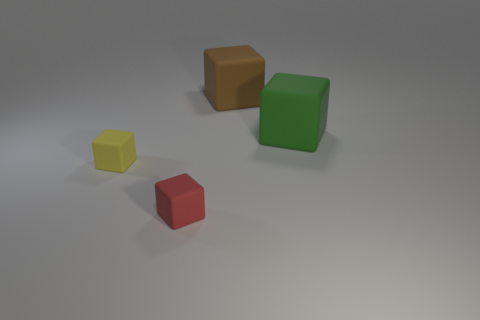Subtract 2 cubes. How many cubes are left? 2 Add 1 big cubes. How many objects exist? 5 Subtract all gray cubes. Subtract all yellow cylinders. How many cubes are left? 4 Subtract 0 purple blocks. How many objects are left? 4 Subtract all green rubber objects. Subtract all tiny red rubber cubes. How many objects are left? 2 Add 2 large cubes. How many large cubes are left? 4 Add 2 cubes. How many cubes exist? 6 